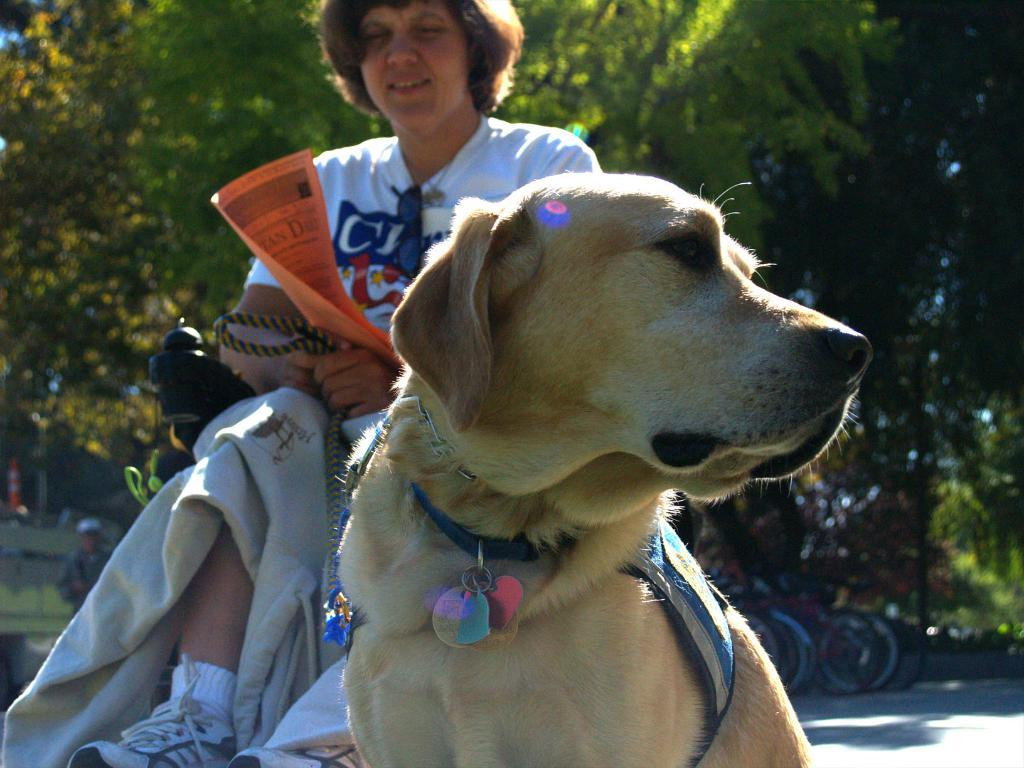What type of animal can be seen in the image? There is a dog in the image. What is the person in the image holding? The person is holding a paper in the image. What can be seen in the background of the image? There are trees and bicycles in the background of the image. What type of oatmeal is being served in the image? There is no oatmeal present in the image. How comfortable is the dog in the image? The comfort level of the dog cannot be determined from the image alone, as it only shows the dog's presence and not its emotional state. 